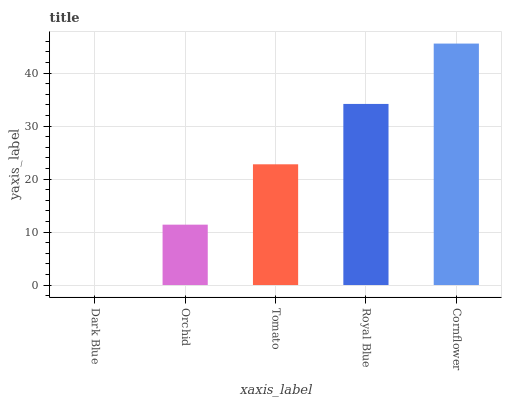Is Orchid the minimum?
Answer yes or no. No. Is Orchid the maximum?
Answer yes or no. No. Is Orchid greater than Dark Blue?
Answer yes or no. Yes. Is Dark Blue less than Orchid?
Answer yes or no. Yes. Is Dark Blue greater than Orchid?
Answer yes or no. No. Is Orchid less than Dark Blue?
Answer yes or no. No. Is Tomato the high median?
Answer yes or no. Yes. Is Tomato the low median?
Answer yes or no. Yes. Is Cornflower the high median?
Answer yes or no. No. Is Royal Blue the low median?
Answer yes or no. No. 